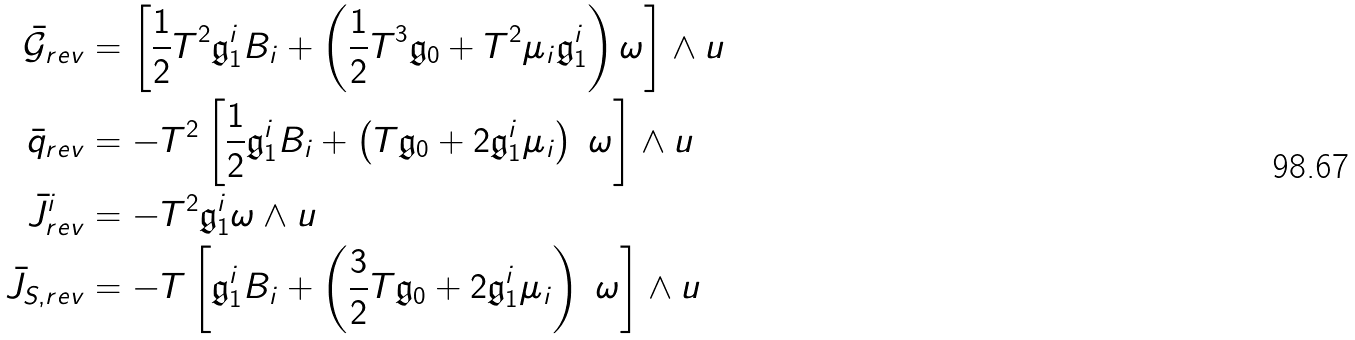<formula> <loc_0><loc_0><loc_500><loc_500>\bar { \mathcal { G } } _ { r e v } & = \left [ \frac { 1 } { 2 } T ^ { 2 } \mathfrak { g } _ { 1 } ^ { i } B _ { i } + \left ( \frac { 1 } { 2 } T ^ { 3 } \mathfrak { g } _ { 0 } + T ^ { 2 } \mu _ { i } \mathfrak { g } _ { 1 } ^ { i } \right ) \omega \right ] \wedge u \\ \bar { q } _ { r e v } & = - T ^ { 2 } \left [ \frac { 1 } { 2 } \mathfrak { g } _ { 1 } ^ { i } B _ { i } + \left ( T \mathfrak { g } _ { 0 } + 2 \mathfrak { g } _ { 1 } ^ { i } \mu _ { i } \right ) \ \omega \right ] \wedge u \\ \bar { J } ^ { i } _ { r e v } & = - T ^ { 2 } \mathfrak { g } _ { 1 } ^ { i } \omega \wedge u \\ \bar { J } _ { S , r e v } & = - T \left [ \mathfrak { g } _ { 1 } ^ { i } B _ { i } + \left ( \frac { 3 } { 2 } T \mathfrak { g } _ { 0 } + 2 \mathfrak { g } _ { 1 } ^ { i } \mu _ { i } \right ) \ \omega \right ] \wedge u \\</formula> 